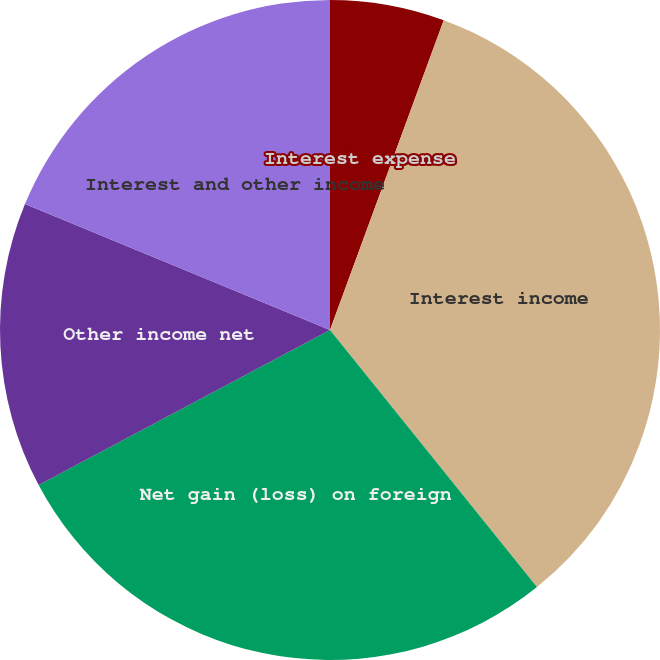Convert chart to OTSL. <chart><loc_0><loc_0><loc_500><loc_500><pie_chart><fcel>Interest expense<fcel>Interest income<fcel>Net gain (loss) on foreign<fcel>Other income net<fcel>Interest and other income<nl><fcel>5.6%<fcel>33.61%<fcel>28.01%<fcel>14.01%<fcel>18.77%<nl></chart> 